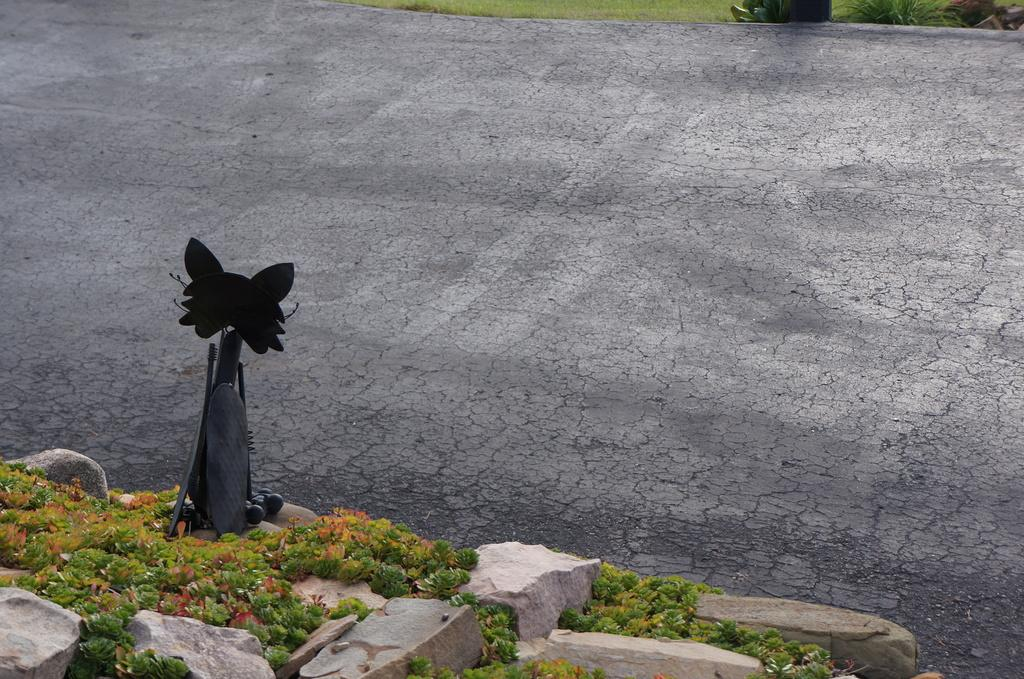What type of vegetation can be seen in the image? There are plants in the image. What other elements can be found in the image besides plants? There are stones present in the image. What is visible at the top of the image? Grass is visible at the top of the image. Can you describe the object on the left side of the image? Unfortunately, the fact only mentions that there is an unspecified object present on the left side of the image, so we cannot provide more details about it. What type of straw is being used to create a thrilling experience in the image? There is no straw present in the image, and the image does not depict any thrilling experiences. 